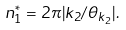<formula> <loc_0><loc_0><loc_500><loc_500>n _ { 1 } ^ { * } = 2 \pi | k _ { 2 } / \theta _ { k _ { 2 } } | .</formula> 